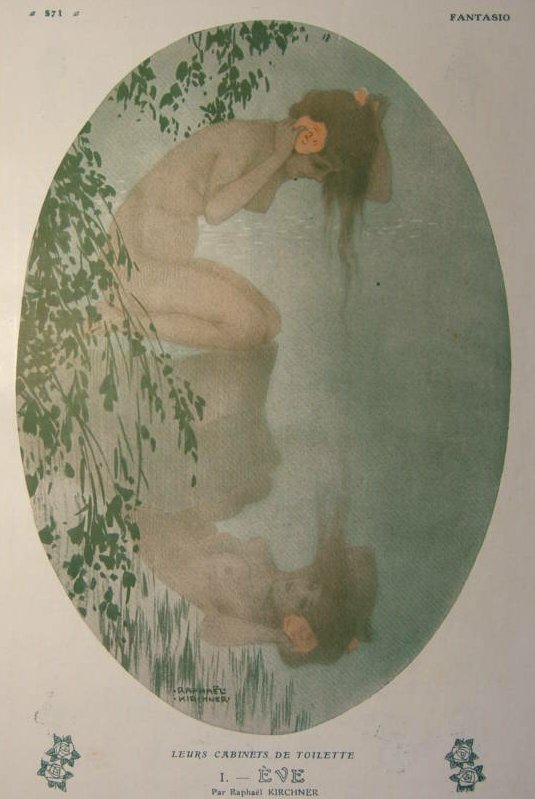If this image were an illustration in a book, what type of book would it be and what would be its theme? If this image were an illustration in a book, it would likely be part of a beautifully illustrated anthology of fairy tales or a romantic fantasy novel. The theme would revolve around nature, serenity, and the ethereal connection between human and environment. The story might delve into mythical narratives, intertwining themes of love, introspection, and the enchanting allure of the natural world. Write a short dialogue between two characters based on this image. Character 1: 'Have you ever seen anything as serene as this place?' 
Character 2: 'No, it's like a hidden gem of tranquility. The way she holds that flower... it's almost as if she’s communing with nature itself.' 
Character 1: 'She's a reflection of the very essence of peace and beauty. I wonder what stories lie behind that calm facade.' 